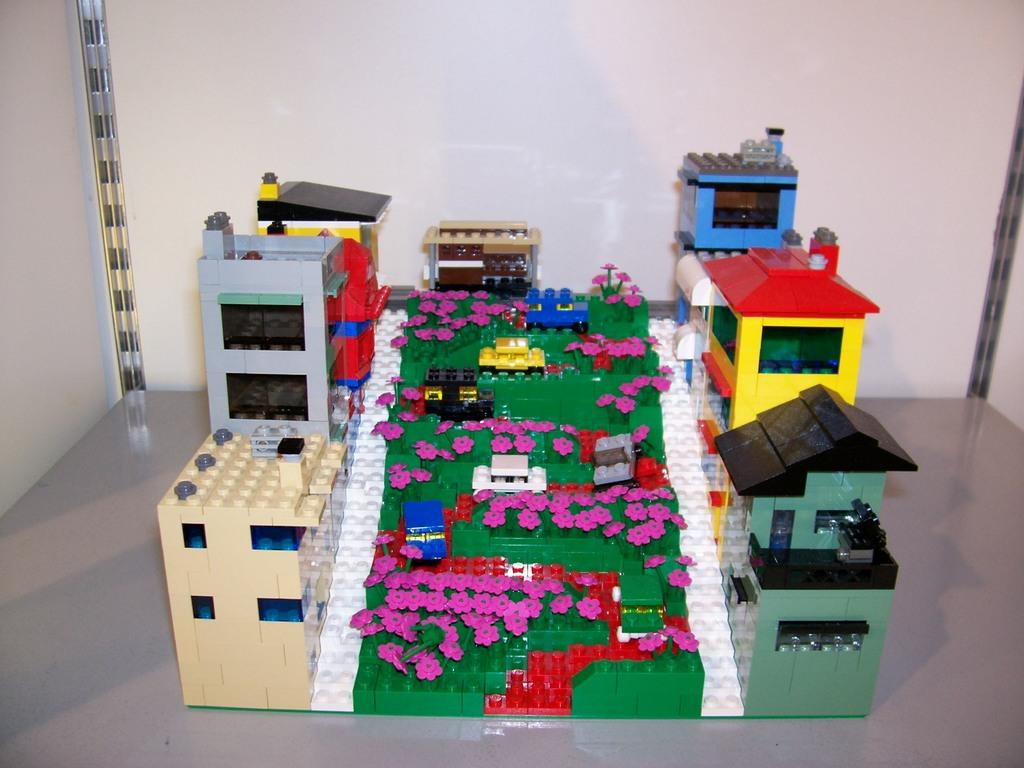What type of toys are visible in the image? There are Lego toys in the image. What can be seen in the background of the image? There is a wall in the background of the image. What is at the bottom of the image? There is a floor at the bottom of the image. Are there any cobwebs visible on the Lego toys in the image? There is no mention of cobwebs in the provided facts, so we cannot determine if any are present in the image. 